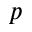Convert formula to latex. <formula><loc_0><loc_0><loc_500><loc_500>_ { p }</formula> 